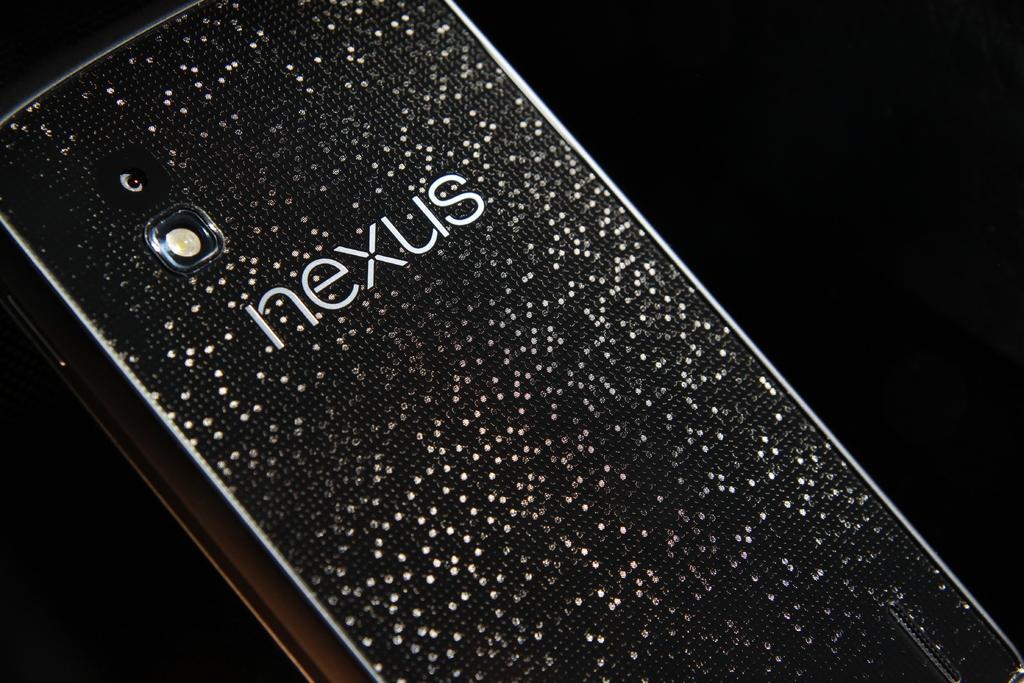What brand is it?
Keep it short and to the point. Nexus. 